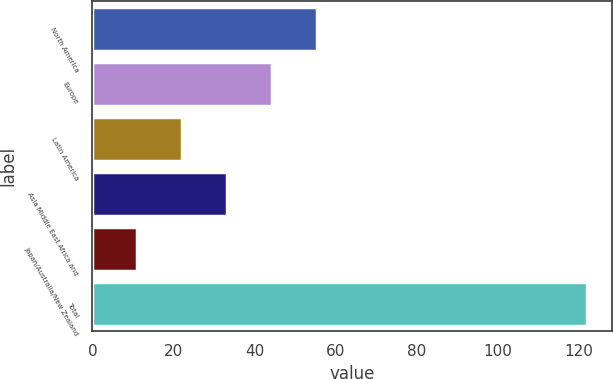Convert chart. <chart><loc_0><loc_0><loc_500><loc_500><bar_chart><fcel>North America<fcel>Europe<fcel>Latin America<fcel>Asia Middle East Africa and<fcel>Japan/Australia/New Zealand<fcel>Total<nl><fcel>55.4<fcel>44.3<fcel>22.1<fcel>33.2<fcel>11<fcel>122<nl></chart> 